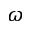Convert formula to latex. <formula><loc_0><loc_0><loc_500><loc_500>\omega</formula> 